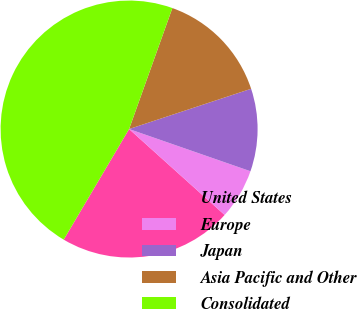Convert chart. <chart><loc_0><loc_0><loc_500><loc_500><pie_chart><fcel>United States<fcel>Europe<fcel>Japan<fcel>Asia Pacific and Other<fcel>Consolidated<nl><fcel>21.84%<fcel>6.33%<fcel>10.4%<fcel>14.46%<fcel>46.97%<nl></chart> 